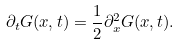<formula> <loc_0><loc_0><loc_500><loc_500>\partial _ { t } G ( x , t ) = \frac { 1 } { 2 } \partial ^ { 2 } _ { x } G ( x , t ) .</formula> 